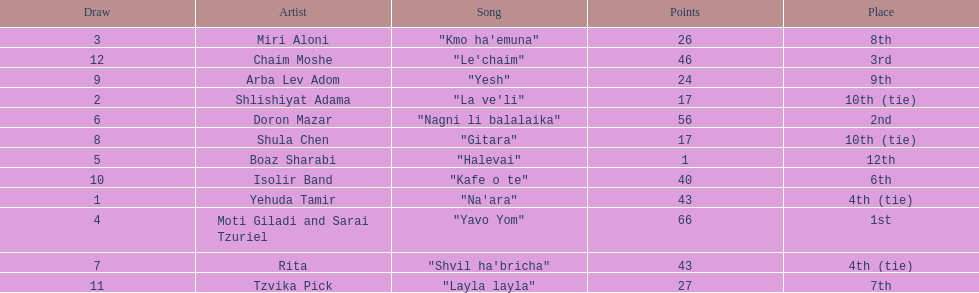Who were all the artists at the contest? Yehuda Tamir, Shlishiyat Adama, Miri Aloni, Moti Giladi and Sarai Tzuriel, Boaz Sharabi, Doron Mazar, Rita, Shula Chen, Arba Lev Adom, Isolir Band, Tzvika Pick, Chaim Moshe. What were their point totals? 43, 17, 26, 66, 1, 56, 43, 17, 24, 40, 27, 46. Of these, which is the least amount of points? 1. Which artists received this point total? Boaz Sharabi. 